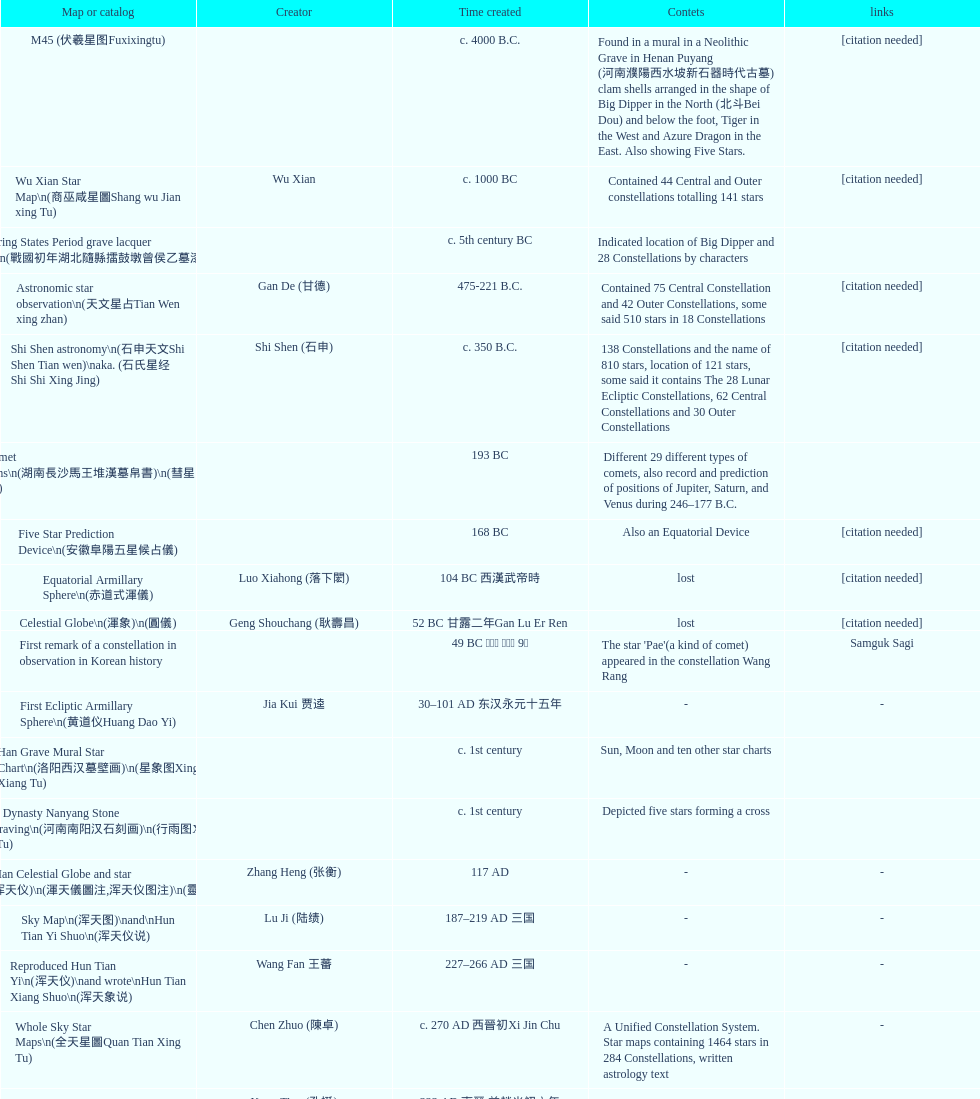Name three items created not long after the equatorial armillary sphere. Celestial Globe (渾象) (圓儀), First remark of a constellation in observation in Korean history, First Ecliptic Armillary Sphere (黄道仪Huang Dao Yi). 